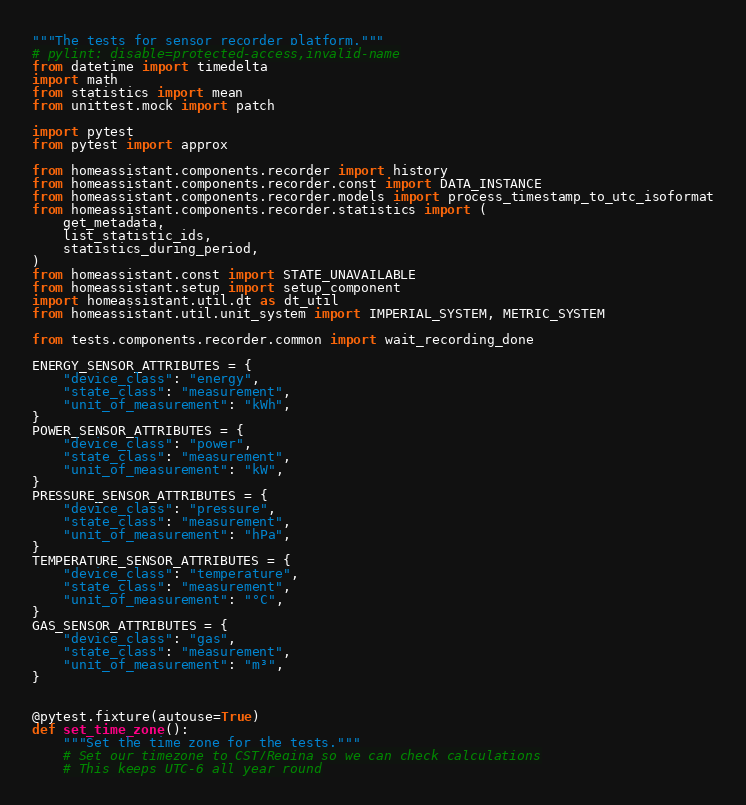Convert code to text. <code><loc_0><loc_0><loc_500><loc_500><_Python_>"""The tests for sensor recorder platform."""
# pylint: disable=protected-access,invalid-name
from datetime import timedelta
import math
from statistics import mean
from unittest.mock import patch

import pytest
from pytest import approx

from homeassistant.components.recorder import history
from homeassistant.components.recorder.const import DATA_INSTANCE
from homeassistant.components.recorder.models import process_timestamp_to_utc_isoformat
from homeassistant.components.recorder.statistics import (
    get_metadata,
    list_statistic_ids,
    statistics_during_period,
)
from homeassistant.const import STATE_UNAVAILABLE
from homeassistant.setup import setup_component
import homeassistant.util.dt as dt_util
from homeassistant.util.unit_system import IMPERIAL_SYSTEM, METRIC_SYSTEM

from tests.components.recorder.common import wait_recording_done

ENERGY_SENSOR_ATTRIBUTES = {
    "device_class": "energy",
    "state_class": "measurement",
    "unit_of_measurement": "kWh",
}
POWER_SENSOR_ATTRIBUTES = {
    "device_class": "power",
    "state_class": "measurement",
    "unit_of_measurement": "kW",
}
PRESSURE_SENSOR_ATTRIBUTES = {
    "device_class": "pressure",
    "state_class": "measurement",
    "unit_of_measurement": "hPa",
}
TEMPERATURE_SENSOR_ATTRIBUTES = {
    "device_class": "temperature",
    "state_class": "measurement",
    "unit_of_measurement": "°C",
}
GAS_SENSOR_ATTRIBUTES = {
    "device_class": "gas",
    "state_class": "measurement",
    "unit_of_measurement": "m³",
}


@pytest.fixture(autouse=True)
def set_time_zone():
    """Set the time zone for the tests."""
    # Set our timezone to CST/Regina so we can check calculations
    # This keeps UTC-6 all year round</code> 